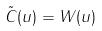<formula> <loc_0><loc_0><loc_500><loc_500>\tilde { C } ( u ) = W ( u )</formula> 